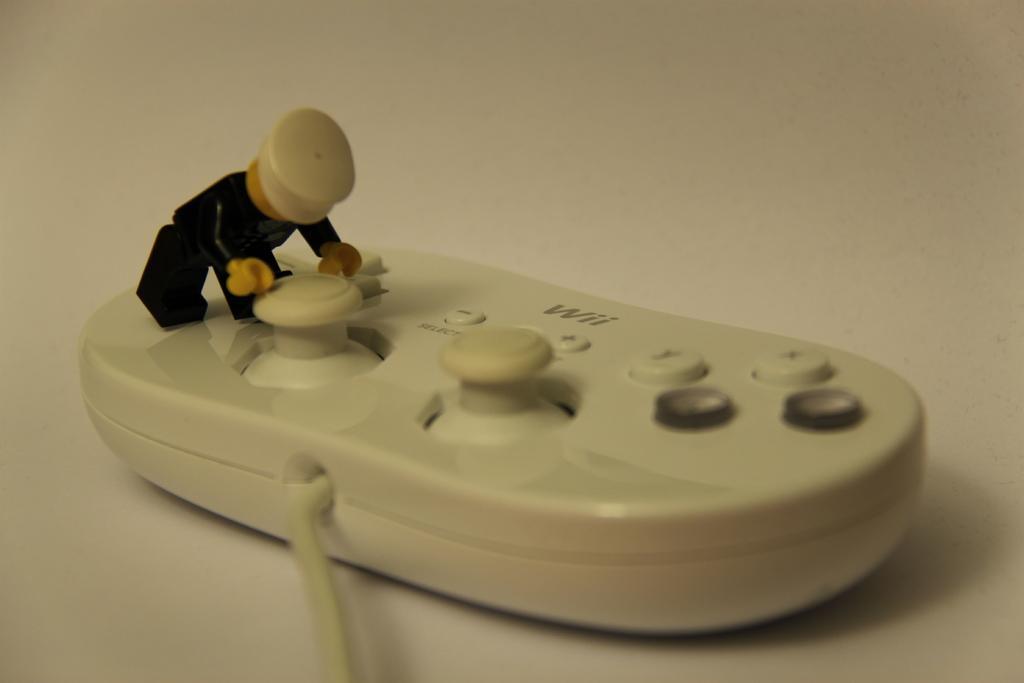Can you describe this image briefly? In this image there is a joystick. On it there is a toy. 